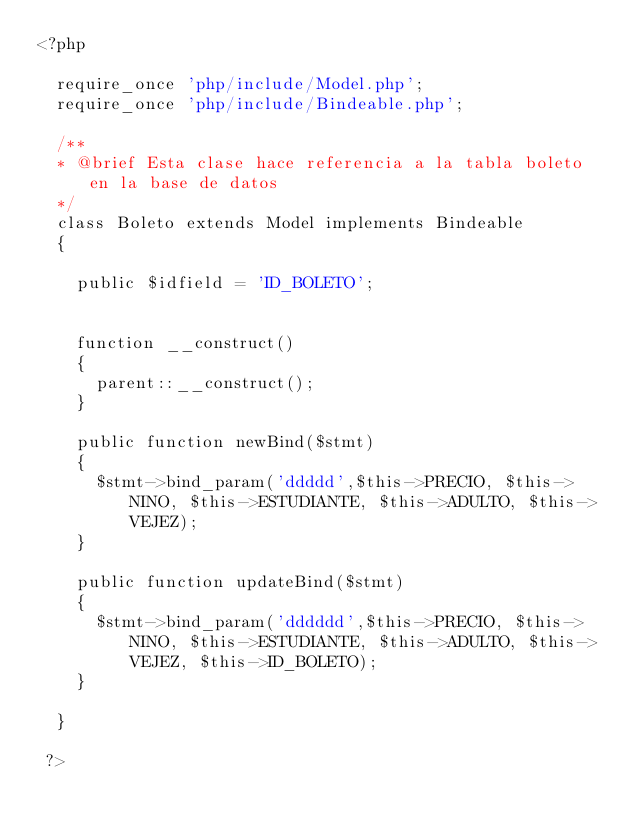<code> <loc_0><loc_0><loc_500><loc_500><_PHP_><?php 

	require_once 'php/include/Model.php';
	require_once 'php/include/Bindeable.php';

	/**
	* @brief Esta clase hace referencia a la tabla boleto en la base de datos
	*/
	class Boleto extends Model implements Bindeable
	{

		public $idfield = 'ID_BOLETO';


		function __construct()
		{
			parent::__construct();
		}

		public function newBind($stmt)
		{
			$stmt->bind_param('ddddd',$this->PRECIO, $this->NINO, $this->ESTUDIANTE, $this->ADULTO, $this->VEJEZ);
		}

		public function updateBind($stmt)
		{
			$stmt->bind_param('dddddd',$this->PRECIO, $this->NINO, $this->ESTUDIANTE, $this->ADULTO, $this->VEJEZ, $this->ID_BOLETO);
		}

	}
	
 ?></code> 